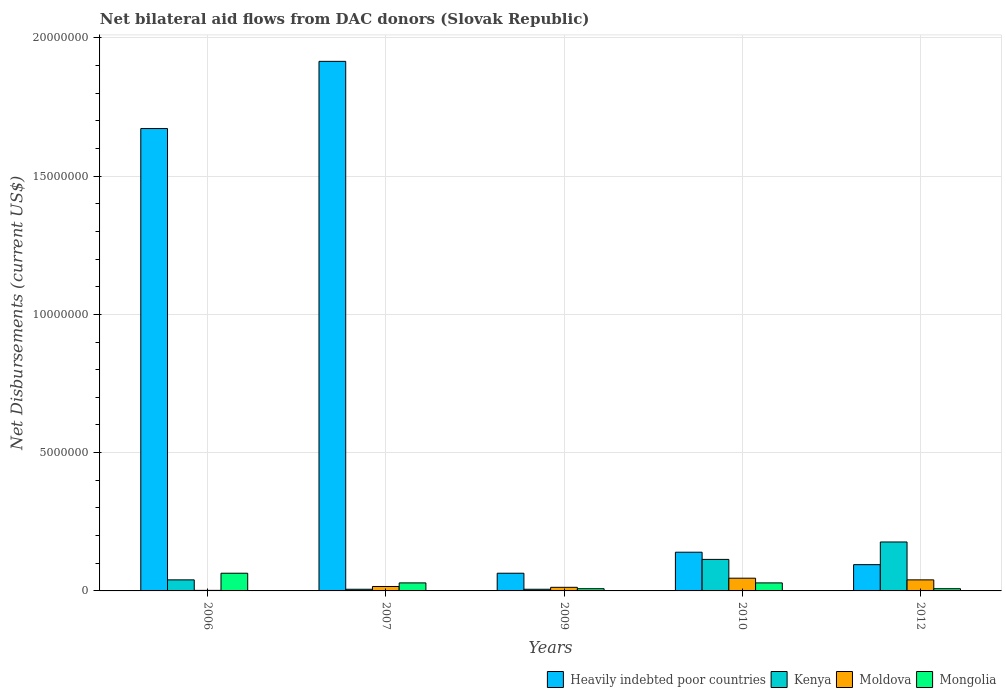How many groups of bars are there?
Your answer should be very brief. 5. Are the number of bars per tick equal to the number of legend labels?
Your answer should be compact. Yes. Are the number of bars on each tick of the X-axis equal?
Give a very brief answer. Yes. How many bars are there on the 5th tick from the right?
Give a very brief answer. 4. Across all years, what is the minimum net bilateral aid flows in Heavily indebted poor countries?
Keep it short and to the point. 6.40e+05. In which year was the net bilateral aid flows in Mongolia maximum?
Your response must be concise. 2006. What is the total net bilateral aid flows in Heavily indebted poor countries in the graph?
Offer a terse response. 3.89e+07. What is the difference between the net bilateral aid flows in Mongolia in 2010 and that in 2012?
Provide a short and direct response. 2.10e+05. What is the difference between the net bilateral aid flows in Heavily indebted poor countries in 2010 and the net bilateral aid flows in Kenya in 2009?
Your answer should be very brief. 1.34e+06. What is the average net bilateral aid flows in Moldova per year?
Offer a very short reply. 2.34e+05. In the year 2012, what is the difference between the net bilateral aid flows in Kenya and net bilateral aid flows in Mongolia?
Keep it short and to the point. 1.69e+06. What is the ratio of the net bilateral aid flows in Mongolia in 2009 to that in 2010?
Ensure brevity in your answer.  0.28. What is the difference between the highest and the second highest net bilateral aid flows in Heavily indebted poor countries?
Offer a very short reply. 2.43e+06. What is the difference between the highest and the lowest net bilateral aid flows in Heavily indebted poor countries?
Your answer should be very brief. 1.85e+07. In how many years, is the net bilateral aid flows in Kenya greater than the average net bilateral aid flows in Kenya taken over all years?
Make the answer very short. 2. Is the sum of the net bilateral aid flows in Moldova in 2006 and 2007 greater than the maximum net bilateral aid flows in Heavily indebted poor countries across all years?
Give a very brief answer. No. Is it the case that in every year, the sum of the net bilateral aid flows in Mongolia and net bilateral aid flows in Heavily indebted poor countries is greater than the sum of net bilateral aid flows in Kenya and net bilateral aid flows in Moldova?
Keep it short and to the point. Yes. What does the 3rd bar from the left in 2009 represents?
Your response must be concise. Moldova. What does the 4th bar from the right in 2007 represents?
Give a very brief answer. Heavily indebted poor countries. Is it the case that in every year, the sum of the net bilateral aid flows in Kenya and net bilateral aid flows in Mongolia is greater than the net bilateral aid flows in Heavily indebted poor countries?
Offer a terse response. No. How many bars are there?
Keep it short and to the point. 20. Are all the bars in the graph horizontal?
Offer a terse response. No. Are the values on the major ticks of Y-axis written in scientific E-notation?
Your answer should be compact. No. How many legend labels are there?
Your answer should be compact. 4. What is the title of the graph?
Offer a very short reply. Net bilateral aid flows from DAC donors (Slovak Republic). Does "Mali" appear as one of the legend labels in the graph?
Your answer should be compact. No. What is the label or title of the Y-axis?
Make the answer very short. Net Disbursements (current US$). What is the Net Disbursements (current US$) in Heavily indebted poor countries in 2006?
Offer a terse response. 1.67e+07. What is the Net Disbursements (current US$) of Kenya in 2006?
Ensure brevity in your answer.  4.00e+05. What is the Net Disbursements (current US$) of Mongolia in 2006?
Your answer should be compact. 6.40e+05. What is the Net Disbursements (current US$) in Heavily indebted poor countries in 2007?
Give a very brief answer. 1.92e+07. What is the Net Disbursements (current US$) of Kenya in 2007?
Offer a terse response. 6.00e+04. What is the Net Disbursements (current US$) in Mongolia in 2007?
Provide a short and direct response. 2.90e+05. What is the Net Disbursements (current US$) in Heavily indebted poor countries in 2009?
Provide a succinct answer. 6.40e+05. What is the Net Disbursements (current US$) in Moldova in 2009?
Provide a succinct answer. 1.30e+05. What is the Net Disbursements (current US$) in Mongolia in 2009?
Your answer should be very brief. 8.00e+04. What is the Net Disbursements (current US$) in Heavily indebted poor countries in 2010?
Offer a terse response. 1.40e+06. What is the Net Disbursements (current US$) in Kenya in 2010?
Your answer should be very brief. 1.14e+06. What is the Net Disbursements (current US$) in Moldova in 2010?
Give a very brief answer. 4.60e+05. What is the Net Disbursements (current US$) in Heavily indebted poor countries in 2012?
Your response must be concise. 9.50e+05. What is the Net Disbursements (current US$) in Kenya in 2012?
Ensure brevity in your answer.  1.77e+06. What is the Net Disbursements (current US$) in Moldova in 2012?
Your answer should be very brief. 4.00e+05. What is the Net Disbursements (current US$) of Mongolia in 2012?
Offer a very short reply. 8.00e+04. Across all years, what is the maximum Net Disbursements (current US$) of Heavily indebted poor countries?
Your response must be concise. 1.92e+07. Across all years, what is the maximum Net Disbursements (current US$) in Kenya?
Make the answer very short. 1.77e+06. Across all years, what is the maximum Net Disbursements (current US$) of Mongolia?
Your answer should be compact. 6.40e+05. Across all years, what is the minimum Net Disbursements (current US$) in Heavily indebted poor countries?
Your answer should be very brief. 6.40e+05. Across all years, what is the minimum Net Disbursements (current US$) in Kenya?
Ensure brevity in your answer.  6.00e+04. Across all years, what is the minimum Net Disbursements (current US$) of Moldova?
Keep it short and to the point. 2.00e+04. What is the total Net Disbursements (current US$) in Heavily indebted poor countries in the graph?
Provide a succinct answer. 3.89e+07. What is the total Net Disbursements (current US$) of Kenya in the graph?
Make the answer very short. 3.43e+06. What is the total Net Disbursements (current US$) of Moldova in the graph?
Offer a terse response. 1.17e+06. What is the total Net Disbursements (current US$) of Mongolia in the graph?
Offer a terse response. 1.38e+06. What is the difference between the Net Disbursements (current US$) of Heavily indebted poor countries in 2006 and that in 2007?
Keep it short and to the point. -2.43e+06. What is the difference between the Net Disbursements (current US$) in Moldova in 2006 and that in 2007?
Your answer should be very brief. -1.40e+05. What is the difference between the Net Disbursements (current US$) in Heavily indebted poor countries in 2006 and that in 2009?
Provide a succinct answer. 1.61e+07. What is the difference between the Net Disbursements (current US$) in Kenya in 2006 and that in 2009?
Provide a succinct answer. 3.40e+05. What is the difference between the Net Disbursements (current US$) of Moldova in 2006 and that in 2009?
Give a very brief answer. -1.10e+05. What is the difference between the Net Disbursements (current US$) in Mongolia in 2006 and that in 2009?
Keep it short and to the point. 5.60e+05. What is the difference between the Net Disbursements (current US$) in Heavily indebted poor countries in 2006 and that in 2010?
Give a very brief answer. 1.53e+07. What is the difference between the Net Disbursements (current US$) in Kenya in 2006 and that in 2010?
Offer a very short reply. -7.40e+05. What is the difference between the Net Disbursements (current US$) of Moldova in 2006 and that in 2010?
Provide a short and direct response. -4.40e+05. What is the difference between the Net Disbursements (current US$) of Mongolia in 2006 and that in 2010?
Your answer should be compact. 3.50e+05. What is the difference between the Net Disbursements (current US$) of Heavily indebted poor countries in 2006 and that in 2012?
Provide a short and direct response. 1.58e+07. What is the difference between the Net Disbursements (current US$) in Kenya in 2006 and that in 2012?
Offer a very short reply. -1.37e+06. What is the difference between the Net Disbursements (current US$) in Moldova in 2006 and that in 2012?
Make the answer very short. -3.80e+05. What is the difference between the Net Disbursements (current US$) of Mongolia in 2006 and that in 2012?
Your answer should be very brief. 5.60e+05. What is the difference between the Net Disbursements (current US$) of Heavily indebted poor countries in 2007 and that in 2009?
Keep it short and to the point. 1.85e+07. What is the difference between the Net Disbursements (current US$) in Kenya in 2007 and that in 2009?
Provide a short and direct response. 0. What is the difference between the Net Disbursements (current US$) in Mongolia in 2007 and that in 2009?
Provide a succinct answer. 2.10e+05. What is the difference between the Net Disbursements (current US$) in Heavily indebted poor countries in 2007 and that in 2010?
Offer a very short reply. 1.78e+07. What is the difference between the Net Disbursements (current US$) of Kenya in 2007 and that in 2010?
Your answer should be very brief. -1.08e+06. What is the difference between the Net Disbursements (current US$) of Moldova in 2007 and that in 2010?
Provide a succinct answer. -3.00e+05. What is the difference between the Net Disbursements (current US$) in Heavily indebted poor countries in 2007 and that in 2012?
Your answer should be very brief. 1.82e+07. What is the difference between the Net Disbursements (current US$) in Kenya in 2007 and that in 2012?
Provide a short and direct response. -1.71e+06. What is the difference between the Net Disbursements (current US$) in Heavily indebted poor countries in 2009 and that in 2010?
Make the answer very short. -7.60e+05. What is the difference between the Net Disbursements (current US$) in Kenya in 2009 and that in 2010?
Your response must be concise. -1.08e+06. What is the difference between the Net Disbursements (current US$) in Moldova in 2009 and that in 2010?
Your answer should be compact. -3.30e+05. What is the difference between the Net Disbursements (current US$) of Heavily indebted poor countries in 2009 and that in 2012?
Give a very brief answer. -3.10e+05. What is the difference between the Net Disbursements (current US$) of Kenya in 2009 and that in 2012?
Your answer should be very brief. -1.71e+06. What is the difference between the Net Disbursements (current US$) in Heavily indebted poor countries in 2010 and that in 2012?
Keep it short and to the point. 4.50e+05. What is the difference between the Net Disbursements (current US$) of Kenya in 2010 and that in 2012?
Give a very brief answer. -6.30e+05. What is the difference between the Net Disbursements (current US$) of Heavily indebted poor countries in 2006 and the Net Disbursements (current US$) of Kenya in 2007?
Your response must be concise. 1.67e+07. What is the difference between the Net Disbursements (current US$) of Heavily indebted poor countries in 2006 and the Net Disbursements (current US$) of Moldova in 2007?
Provide a succinct answer. 1.66e+07. What is the difference between the Net Disbursements (current US$) of Heavily indebted poor countries in 2006 and the Net Disbursements (current US$) of Mongolia in 2007?
Your answer should be compact. 1.64e+07. What is the difference between the Net Disbursements (current US$) in Kenya in 2006 and the Net Disbursements (current US$) in Moldova in 2007?
Provide a short and direct response. 2.40e+05. What is the difference between the Net Disbursements (current US$) of Kenya in 2006 and the Net Disbursements (current US$) of Mongolia in 2007?
Ensure brevity in your answer.  1.10e+05. What is the difference between the Net Disbursements (current US$) of Moldova in 2006 and the Net Disbursements (current US$) of Mongolia in 2007?
Offer a very short reply. -2.70e+05. What is the difference between the Net Disbursements (current US$) of Heavily indebted poor countries in 2006 and the Net Disbursements (current US$) of Kenya in 2009?
Offer a very short reply. 1.67e+07. What is the difference between the Net Disbursements (current US$) of Heavily indebted poor countries in 2006 and the Net Disbursements (current US$) of Moldova in 2009?
Keep it short and to the point. 1.66e+07. What is the difference between the Net Disbursements (current US$) of Heavily indebted poor countries in 2006 and the Net Disbursements (current US$) of Mongolia in 2009?
Your answer should be very brief. 1.66e+07. What is the difference between the Net Disbursements (current US$) of Kenya in 2006 and the Net Disbursements (current US$) of Mongolia in 2009?
Keep it short and to the point. 3.20e+05. What is the difference between the Net Disbursements (current US$) in Heavily indebted poor countries in 2006 and the Net Disbursements (current US$) in Kenya in 2010?
Your answer should be compact. 1.56e+07. What is the difference between the Net Disbursements (current US$) in Heavily indebted poor countries in 2006 and the Net Disbursements (current US$) in Moldova in 2010?
Make the answer very short. 1.63e+07. What is the difference between the Net Disbursements (current US$) in Heavily indebted poor countries in 2006 and the Net Disbursements (current US$) in Mongolia in 2010?
Offer a terse response. 1.64e+07. What is the difference between the Net Disbursements (current US$) in Kenya in 2006 and the Net Disbursements (current US$) in Moldova in 2010?
Keep it short and to the point. -6.00e+04. What is the difference between the Net Disbursements (current US$) in Moldova in 2006 and the Net Disbursements (current US$) in Mongolia in 2010?
Your answer should be compact. -2.70e+05. What is the difference between the Net Disbursements (current US$) in Heavily indebted poor countries in 2006 and the Net Disbursements (current US$) in Kenya in 2012?
Make the answer very short. 1.50e+07. What is the difference between the Net Disbursements (current US$) of Heavily indebted poor countries in 2006 and the Net Disbursements (current US$) of Moldova in 2012?
Offer a very short reply. 1.63e+07. What is the difference between the Net Disbursements (current US$) of Heavily indebted poor countries in 2006 and the Net Disbursements (current US$) of Mongolia in 2012?
Provide a short and direct response. 1.66e+07. What is the difference between the Net Disbursements (current US$) in Kenya in 2006 and the Net Disbursements (current US$) in Moldova in 2012?
Your answer should be compact. 0. What is the difference between the Net Disbursements (current US$) in Heavily indebted poor countries in 2007 and the Net Disbursements (current US$) in Kenya in 2009?
Provide a succinct answer. 1.91e+07. What is the difference between the Net Disbursements (current US$) in Heavily indebted poor countries in 2007 and the Net Disbursements (current US$) in Moldova in 2009?
Offer a terse response. 1.90e+07. What is the difference between the Net Disbursements (current US$) in Heavily indebted poor countries in 2007 and the Net Disbursements (current US$) in Mongolia in 2009?
Offer a very short reply. 1.91e+07. What is the difference between the Net Disbursements (current US$) of Kenya in 2007 and the Net Disbursements (current US$) of Moldova in 2009?
Your answer should be very brief. -7.00e+04. What is the difference between the Net Disbursements (current US$) of Kenya in 2007 and the Net Disbursements (current US$) of Mongolia in 2009?
Give a very brief answer. -2.00e+04. What is the difference between the Net Disbursements (current US$) in Heavily indebted poor countries in 2007 and the Net Disbursements (current US$) in Kenya in 2010?
Your answer should be compact. 1.80e+07. What is the difference between the Net Disbursements (current US$) in Heavily indebted poor countries in 2007 and the Net Disbursements (current US$) in Moldova in 2010?
Provide a short and direct response. 1.87e+07. What is the difference between the Net Disbursements (current US$) in Heavily indebted poor countries in 2007 and the Net Disbursements (current US$) in Mongolia in 2010?
Your answer should be compact. 1.89e+07. What is the difference between the Net Disbursements (current US$) in Kenya in 2007 and the Net Disbursements (current US$) in Moldova in 2010?
Offer a very short reply. -4.00e+05. What is the difference between the Net Disbursements (current US$) of Kenya in 2007 and the Net Disbursements (current US$) of Mongolia in 2010?
Keep it short and to the point. -2.30e+05. What is the difference between the Net Disbursements (current US$) in Heavily indebted poor countries in 2007 and the Net Disbursements (current US$) in Kenya in 2012?
Give a very brief answer. 1.74e+07. What is the difference between the Net Disbursements (current US$) in Heavily indebted poor countries in 2007 and the Net Disbursements (current US$) in Moldova in 2012?
Give a very brief answer. 1.88e+07. What is the difference between the Net Disbursements (current US$) of Heavily indebted poor countries in 2007 and the Net Disbursements (current US$) of Mongolia in 2012?
Keep it short and to the point. 1.91e+07. What is the difference between the Net Disbursements (current US$) in Kenya in 2007 and the Net Disbursements (current US$) in Moldova in 2012?
Your response must be concise. -3.40e+05. What is the difference between the Net Disbursements (current US$) of Kenya in 2007 and the Net Disbursements (current US$) of Mongolia in 2012?
Ensure brevity in your answer.  -2.00e+04. What is the difference between the Net Disbursements (current US$) of Moldova in 2007 and the Net Disbursements (current US$) of Mongolia in 2012?
Keep it short and to the point. 8.00e+04. What is the difference between the Net Disbursements (current US$) in Heavily indebted poor countries in 2009 and the Net Disbursements (current US$) in Kenya in 2010?
Provide a short and direct response. -5.00e+05. What is the difference between the Net Disbursements (current US$) in Heavily indebted poor countries in 2009 and the Net Disbursements (current US$) in Moldova in 2010?
Provide a short and direct response. 1.80e+05. What is the difference between the Net Disbursements (current US$) in Kenya in 2009 and the Net Disbursements (current US$) in Moldova in 2010?
Give a very brief answer. -4.00e+05. What is the difference between the Net Disbursements (current US$) of Kenya in 2009 and the Net Disbursements (current US$) of Mongolia in 2010?
Your response must be concise. -2.30e+05. What is the difference between the Net Disbursements (current US$) in Heavily indebted poor countries in 2009 and the Net Disbursements (current US$) in Kenya in 2012?
Your response must be concise. -1.13e+06. What is the difference between the Net Disbursements (current US$) of Heavily indebted poor countries in 2009 and the Net Disbursements (current US$) of Moldova in 2012?
Provide a short and direct response. 2.40e+05. What is the difference between the Net Disbursements (current US$) in Heavily indebted poor countries in 2009 and the Net Disbursements (current US$) in Mongolia in 2012?
Make the answer very short. 5.60e+05. What is the difference between the Net Disbursements (current US$) in Moldova in 2009 and the Net Disbursements (current US$) in Mongolia in 2012?
Keep it short and to the point. 5.00e+04. What is the difference between the Net Disbursements (current US$) in Heavily indebted poor countries in 2010 and the Net Disbursements (current US$) in Kenya in 2012?
Keep it short and to the point. -3.70e+05. What is the difference between the Net Disbursements (current US$) of Heavily indebted poor countries in 2010 and the Net Disbursements (current US$) of Moldova in 2012?
Offer a terse response. 1.00e+06. What is the difference between the Net Disbursements (current US$) in Heavily indebted poor countries in 2010 and the Net Disbursements (current US$) in Mongolia in 2012?
Your response must be concise. 1.32e+06. What is the difference between the Net Disbursements (current US$) of Kenya in 2010 and the Net Disbursements (current US$) of Moldova in 2012?
Make the answer very short. 7.40e+05. What is the difference between the Net Disbursements (current US$) of Kenya in 2010 and the Net Disbursements (current US$) of Mongolia in 2012?
Give a very brief answer. 1.06e+06. What is the difference between the Net Disbursements (current US$) of Moldova in 2010 and the Net Disbursements (current US$) of Mongolia in 2012?
Ensure brevity in your answer.  3.80e+05. What is the average Net Disbursements (current US$) in Heavily indebted poor countries per year?
Give a very brief answer. 7.77e+06. What is the average Net Disbursements (current US$) of Kenya per year?
Provide a short and direct response. 6.86e+05. What is the average Net Disbursements (current US$) of Moldova per year?
Ensure brevity in your answer.  2.34e+05. What is the average Net Disbursements (current US$) in Mongolia per year?
Ensure brevity in your answer.  2.76e+05. In the year 2006, what is the difference between the Net Disbursements (current US$) in Heavily indebted poor countries and Net Disbursements (current US$) in Kenya?
Offer a very short reply. 1.63e+07. In the year 2006, what is the difference between the Net Disbursements (current US$) of Heavily indebted poor countries and Net Disbursements (current US$) of Moldova?
Offer a very short reply. 1.67e+07. In the year 2006, what is the difference between the Net Disbursements (current US$) in Heavily indebted poor countries and Net Disbursements (current US$) in Mongolia?
Provide a succinct answer. 1.61e+07. In the year 2006, what is the difference between the Net Disbursements (current US$) in Kenya and Net Disbursements (current US$) in Moldova?
Keep it short and to the point. 3.80e+05. In the year 2006, what is the difference between the Net Disbursements (current US$) in Kenya and Net Disbursements (current US$) in Mongolia?
Make the answer very short. -2.40e+05. In the year 2006, what is the difference between the Net Disbursements (current US$) of Moldova and Net Disbursements (current US$) of Mongolia?
Provide a short and direct response. -6.20e+05. In the year 2007, what is the difference between the Net Disbursements (current US$) in Heavily indebted poor countries and Net Disbursements (current US$) in Kenya?
Offer a very short reply. 1.91e+07. In the year 2007, what is the difference between the Net Disbursements (current US$) of Heavily indebted poor countries and Net Disbursements (current US$) of Moldova?
Your answer should be very brief. 1.90e+07. In the year 2007, what is the difference between the Net Disbursements (current US$) in Heavily indebted poor countries and Net Disbursements (current US$) in Mongolia?
Keep it short and to the point. 1.89e+07. In the year 2009, what is the difference between the Net Disbursements (current US$) of Heavily indebted poor countries and Net Disbursements (current US$) of Kenya?
Your response must be concise. 5.80e+05. In the year 2009, what is the difference between the Net Disbursements (current US$) in Heavily indebted poor countries and Net Disbursements (current US$) in Moldova?
Keep it short and to the point. 5.10e+05. In the year 2009, what is the difference between the Net Disbursements (current US$) of Heavily indebted poor countries and Net Disbursements (current US$) of Mongolia?
Offer a very short reply. 5.60e+05. In the year 2009, what is the difference between the Net Disbursements (current US$) of Kenya and Net Disbursements (current US$) of Moldova?
Keep it short and to the point. -7.00e+04. In the year 2009, what is the difference between the Net Disbursements (current US$) in Kenya and Net Disbursements (current US$) in Mongolia?
Ensure brevity in your answer.  -2.00e+04. In the year 2009, what is the difference between the Net Disbursements (current US$) in Moldova and Net Disbursements (current US$) in Mongolia?
Your answer should be very brief. 5.00e+04. In the year 2010, what is the difference between the Net Disbursements (current US$) in Heavily indebted poor countries and Net Disbursements (current US$) in Moldova?
Your answer should be compact. 9.40e+05. In the year 2010, what is the difference between the Net Disbursements (current US$) in Heavily indebted poor countries and Net Disbursements (current US$) in Mongolia?
Keep it short and to the point. 1.11e+06. In the year 2010, what is the difference between the Net Disbursements (current US$) in Kenya and Net Disbursements (current US$) in Moldova?
Provide a short and direct response. 6.80e+05. In the year 2010, what is the difference between the Net Disbursements (current US$) of Kenya and Net Disbursements (current US$) of Mongolia?
Make the answer very short. 8.50e+05. In the year 2010, what is the difference between the Net Disbursements (current US$) of Moldova and Net Disbursements (current US$) of Mongolia?
Offer a very short reply. 1.70e+05. In the year 2012, what is the difference between the Net Disbursements (current US$) in Heavily indebted poor countries and Net Disbursements (current US$) in Kenya?
Your response must be concise. -8.20e+05. In the year 2012, what is the difference between the Net Disbursements (current US$) in Heavily indebted poor countries and Net Disbursements (current US$) in Moldova?
Ensure brevity in your answer.  5.50e+05. In the year 2012, what is the difference between the Net Disbursements (current US$) in Heavily indebted poor countries and Net Disbursements (current US$) in Mongolia?
Offer a very short reply. 8.70e+05. In the year 2012, what is the difference between the Net Disbursements (current US$) in Kenya and Net Disbursements (current US$) in Moldova?
Provide a succinct answer. 1.37e+06. In the year 2012, what is the difference between the Net Disbursements (current US$) of Kenya and Net Disbursements (current US$) of Mongolia?
Provide a succinct answer. 1.69e+06. What is the ratio of the Net Disbursements (current US$) in Heavily indebted poor countries in 2006 to that in 2007?
Offer a very short reply. 0.87. What is the ratio of the Net Disbursements (current US$) in Kenya in 2006 to that in 2007?
Give a very brief answer. 6.67. What is the ratio of the Net Disbursements (current US$) of Mongolia in 2006 to that in 2007?
Provide a succinct answer. 2.21. What is the ratio of the Net Disbursements (current US$) in Heavily indebted poor countries in 2006 to that in 2009?
Provide a short and direct response. 26.12. What is the ratio of the Net Disbursements (current US$) in Kenya in 2006 to that in 2009?
Offer a very short reply. 6.67. What is the ratio of the Net Disbursements (current US$) in Moldova in 2006 to that in 2009?
Make the answer very short. 0.15. What is the ratio of the Net Disbursements (current US$) of Mongolia in 2006 to that in 2009?
Offer a terse response. 8. What is the ratio of the Net Disbursements (current US$) in Heavily indebted poor countries in 2006 to that in 2010?
Keep it short and to the point. 11.94. What is the ratio of the Net Disbursements (current US$) of Kenya in 2006 to that in 2010?
Your response must be concise. 0.35. What is the ratio of the Net Disbursements (current US$) in Moldova in 2006 to that in 2010?
Provide a short and direct response. 0.04. What is the ratio of the Net Disbursements (current US$) in Mongolia in 2006 to that in 2010?
Keep it short and to the point. 2.21. What is the ratio of the Net Disbursements (current US$) in Kenya in 2006 to that in 2012?
Ensure brevity in your answer.  0.23. What is the ratio of the Net Disbursements (current US$) of Moldova in 2006 to that in 2012?
Your response must be concise. 0.05. What is the ratio of the Net Disbursements (current US$) in Mongolia in 2006 to that in 2012?
Your response must be concise. 8. What is the ratio of the Net Disbursements (current US$) in Heavily indebted poor countries in 2007 to that in 2009?
Provide a short and direct response. 29.92. What is the ratio of the Net Disbursements (current US$) in Kenya in 2007 to that in 2009?
Provide a short and direct response. 1. What is the ratio of the Net Disbursements (current US$) in Moldova in 2007 to that in 2009?
Your answer should be very brief. 1.23. What is the ratio of the Net Disbursements (current US$) in Mongolia in 2007 to that in 2009?
Offer a terse response. 3.62. What is the ratio of the Net Disbursements (current US$) of Heavily indebted poor countries in 2007 to that in 2010?
Make the answer very short. 13.68. What is the ratio of the Net Disbursements (current US$) in Kenya in 2007 to that in 2010?
Keep it short and to the point. 0.05. What is the ratio of the Net Disbursements (current US$) in Moldova in 2007 to that in 2010?
Offer a very short reply. 0.35. What is the ratio of the Net Disbursements (current US$) in Heavily indebted poor countries in 2007 to that in 2012?
Your answer should be very brief. 20.16. What is the ratio of the Net Disbursements (current US$) in Kenya in 2007 to that in 2012?
Ensure brevity in your answer.  0.03. What is the ratio of the Net Disbursements (current US$) of Mongolia in 2007 to that in 2012?
Ensure brevity in your answer.  3.62. What is the ratio of the Net Disbursements (current US$) in Heavily indebted poor countries in 2009 to that in 2010?
Offer a terse response. 0.46. What is the ratio of the Net Disbursements (current US$) in Kenya in 2009 to that in 2010?
Your response must be concise. 0.05. What is the ratio of the Net Disbursements (current US$) of Moldova in 2009 to that in 2010?
Give a very brief answer. 0.28. What is the ratio of the Net Disbursements (current US$) of Mongolia in 2009 to that in 2010?
Make the answer very short. 0.28. What is the ratio of the Net Disbursements (current US$) in Heavily indebted poor countries in 2009 to that in 2012?
Your answer should be compact. 0.67. What is the ratio of the Net Disbursements (current US$) of Kenya in 2009 to that in 2012?
Ensure brevity in your answer.  0.03. What is the ratio of the Net Disbursements (current US$) of Moldova in 2009 to that in 2012?
Give a very brief answer. 0.33. What is the ratio of the Net Disbursements (current US$) in Mongolia in 2009 to that in 2012?
Offer a very short reply. 1. What is the ratio of the Net Disbursements (current US$) of Heavily indebted poor countries in 2010 to that in 2012?
Provide a succinct answer. 1.47. What is the ratio of the Net Disbursements (current US$) in Kenya in 2010 to that in 2012?
Make the answer very short. 0.64. What is the ratio of the Net Disbursements (current US$) of Moldova in 2010 to that in 2012?
Your answer should be compact. 1.15. What is the ratio of the Net Disbursements (current US$) in Mongolia in 2010 to that in 2012?
Keep it short and to the point. 3.62. What is the difference between the highest and the second highest Net Disbursements (current US$) of Heavily indebted poor countries?
Your answer should be compact. 2.43e+06. What is the difference between the highest and the second highest Net Disbursements (current US$) of Kenya?
Give a very brief answer. 6.30e+05. What is the difference between the highest and the second highest Net Disbursements (current US$) in Mongolia?
Your answer should be very brief. 3.50e+05. What is the difference between the highest and the lowest Net Disbursements (current US$) in Heavily indebted poor countries?
Ensure brevity in your answer.  1.85e+07. What is the difference between the highest and the lowest Net Disbursements (current US$) of Kenya?
Give a very brief answer. 1.71e+06. What is the difference between the highest and the lowest Net Disbursements (current US$) of Mongolia?
Provide a succinct answer. 5.60e+05. 